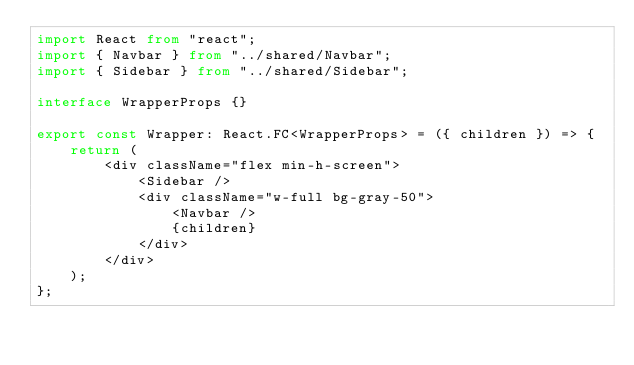<code> <loc_0><loc_0><loc_500><loc_500><_TypeScript_>import React from "react";
import { Navbar } from "../shared/Navbar";
import { Sidebar } from "../shared/Sidebar";

interface WrapperProps {}

export const Wrapper: React.FC<WrapperProps> = ({ children }) => {
    return (
        <div className="flex min-h-screen">
            <Sidebar />
            <div className="w-full bg-gray-50">
                <Navbar />
                {children}
            </div>
        </div>
    );
};
</code> 